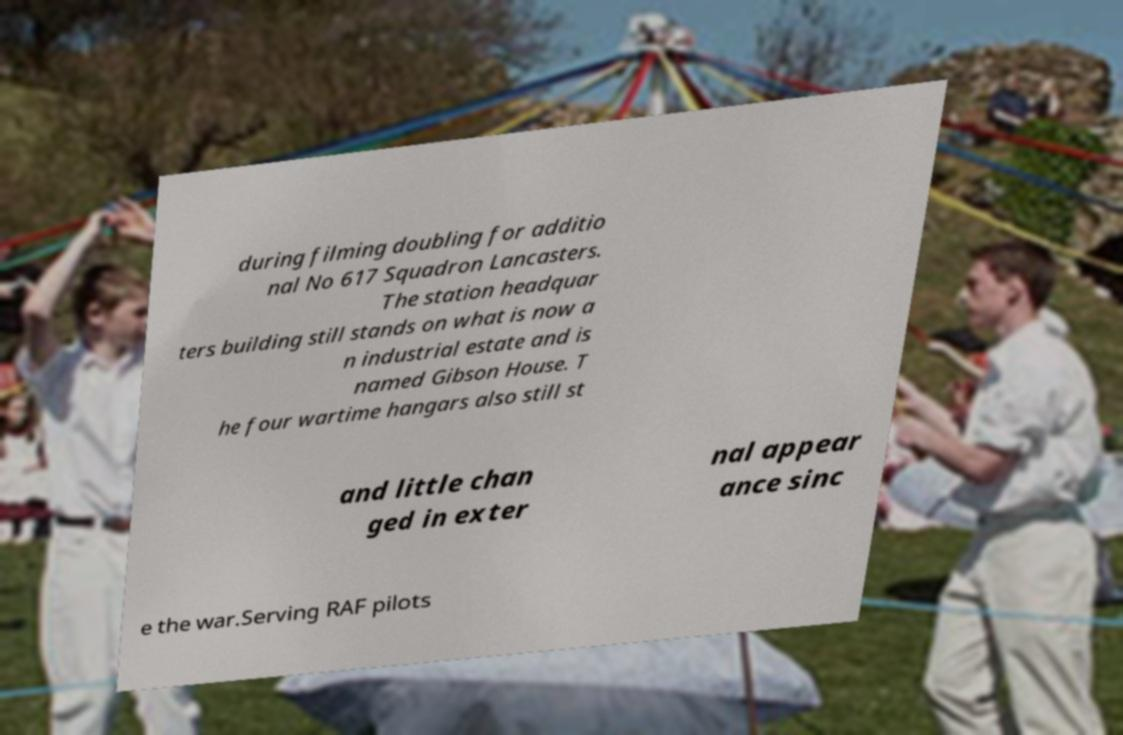Please read and relay the text visible in this image. What does it say? during filming doubling for additio nal No 617 Squadron Lancasters. The station headquar ters building still stands on what is now a n industrial estate and is named Gibson House. T he four wartime hangars also still st and little chan ged in exter nal appear ance sinc e the war.Serving RAF pilots 